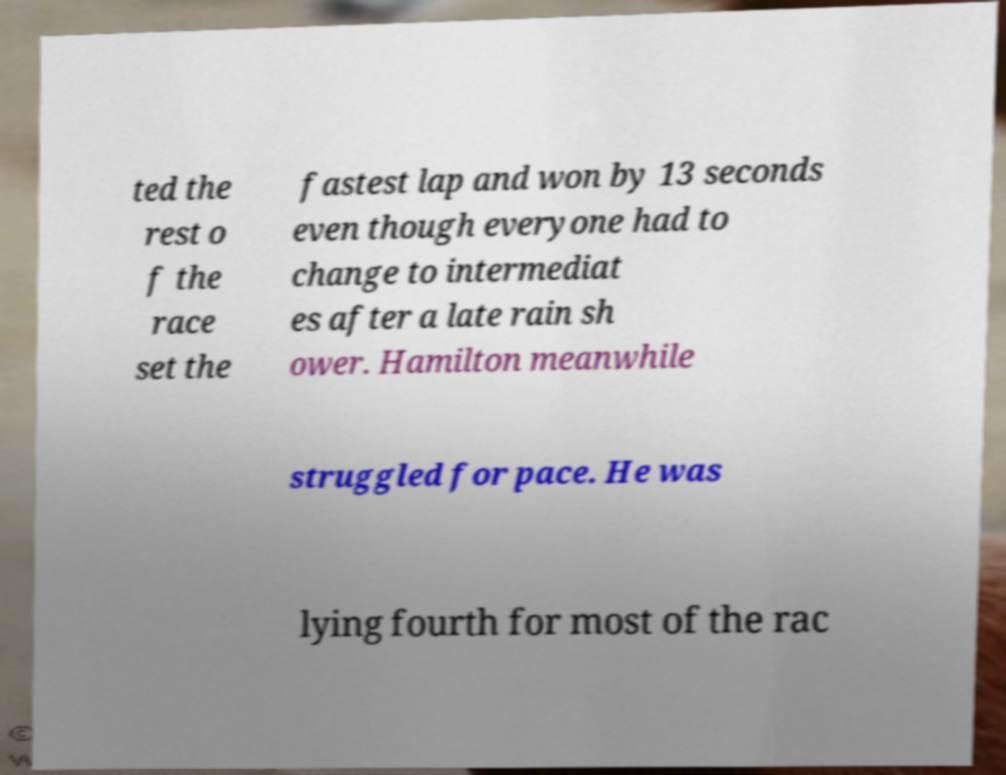Can you read and provide the text displayed in the image?This photo seems to have some interesting text. Can you extract and type it out for me? ted the rest o f the race set the fastest lap and won by 13 seconds even though everyone had to change to intermediat es after a late rain sh ower. Hamilton meanwhile struggled for pace. He was lying fourth for most of the rac 